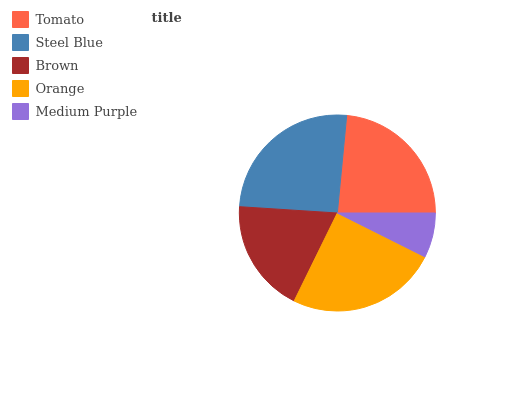Is Medium Purple the minimum?
Answer yes or no. Yes. Is Steel Blue the maximum?
Answer yes or no. Yes. Is Brown the minimum?
Answer yes or no. No. Is Brown the maximum?
Answer yes or no. No. Is Steel Blue greater than Brown?
Answer yes or no. Yes. Is Brown less than Steel Blue?
Answer yes or no. Yes. Is Brown greater than Steel Blue?
Answer yes or no. No. Is Steel Blue less than Brown?
Answer yes or no. No. Is Tomato the high median?
Answer yes or no. Yes. Is Tomato the low median?
Answer yes or no. Yes. Is Steel Blue the high median?
Answer yes or no. No. Is Orange the low median?
Answer yes or no. No. 